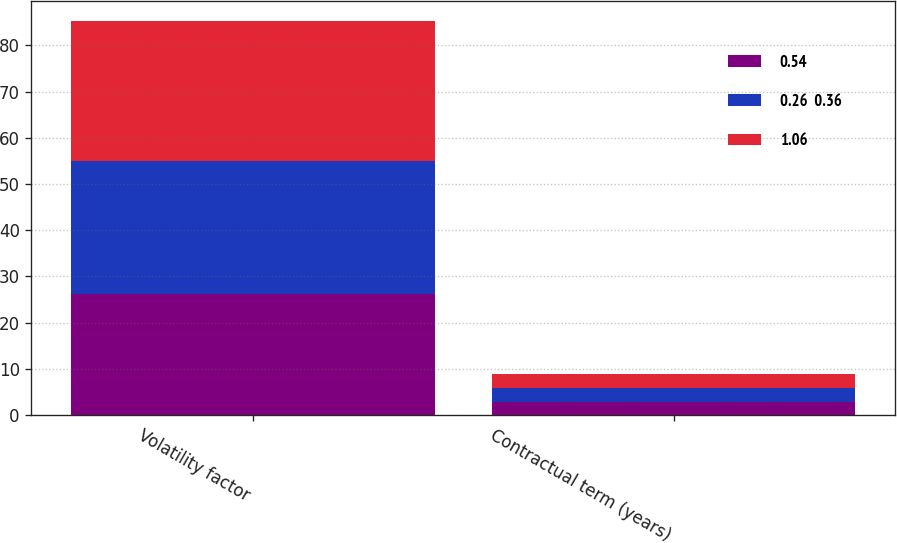Convert chart to OTSL. <chart><loc_0><loc_0><loc_500><loc_500><stacked_bar_chart><ecel><fcel>Volatility factor<fcel>Contractual term (years)<nl><fcel>0.54<fcel>26.2<fcel>2.89<nl><fcel>0.26  0.36<fcel>28.8<fcel>2.89<nl><fcel>1.06<fcel>30.3<fcel>3<nl></chart> 